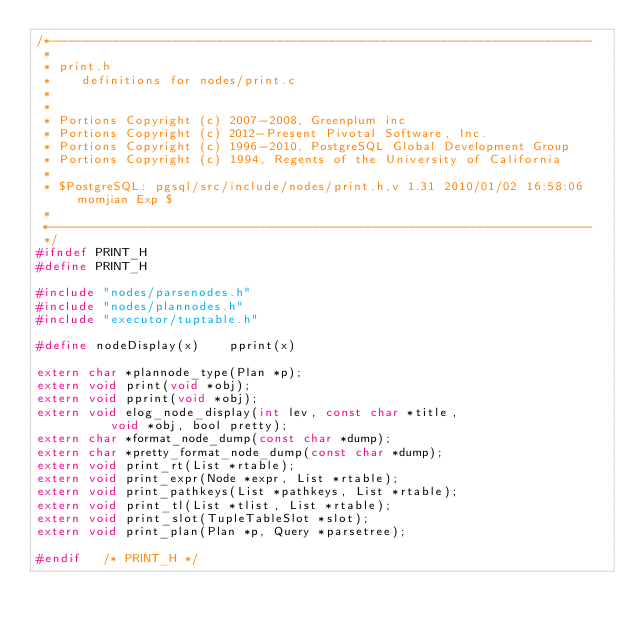Convert code to text. <code><loc_0><loc_0><loc_500><loc_500><_C_>/*-------------------------------------------------------------------------
 *
 * print.h
 *	  definitions for nodes/print.c
 *
 *
 * Portions Copyright (c) 2007-2008, Greenplum inc
 * Portions Copyright (c) 2012-Present Pivotal Software, Inc.
 * Portions Copyright (c) 1996-2010, PostgreSQL Global Development Group
 * Portions Copyright (c) 1994, Regents of the University of California
 *
 * $PostgreSQL: pgsql/src/include/nodes/print.h,v 1.31 2010/01/02 16:58:06 momjian Exp $
 *
 *-------------------------------------------------------------------------
 */
#ifndef PRINT_H
#define PRINT_H

#include "nodes/parsenodes.h"
#include "nodes/plannodes.h"
#include "executor/tuptable.h"

#define nodeDisplay(x)		pprint(x)

extern char *plannode_type(Plan *p);
extern void print(void *obj);
extern void pprint(void *obj);
extern void elog_node_display(int lev, const char *title,
				  void *obj, bool pretty);
extern char *format_node_dump(const char *dump);
extern char *pretty_format_node_dump(const char *dump);
extern void print_rt(List *rtable);
extern void print_expr(Node *expr, List *rtable);
extern void print_pathkeys(List *pathkeys, List *rtable);
extern void print_tl(List *tlist, List *rtable);
extern void print_slot(TupleTableSlot *slot);
extern void print_plan(Plan *p, Query *parsetree);

#endif   /* PRINT_H */
</code> 